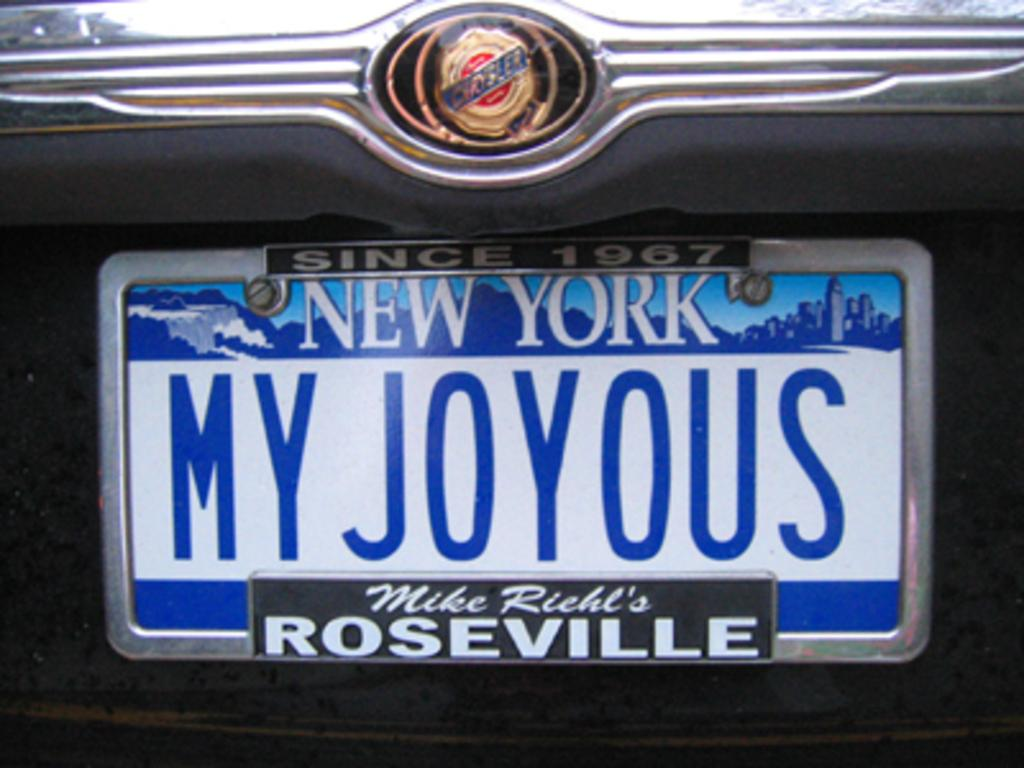<image>
Render a clear and concise summary of the photo. New York license plate stating My Joyous Since 1967. 